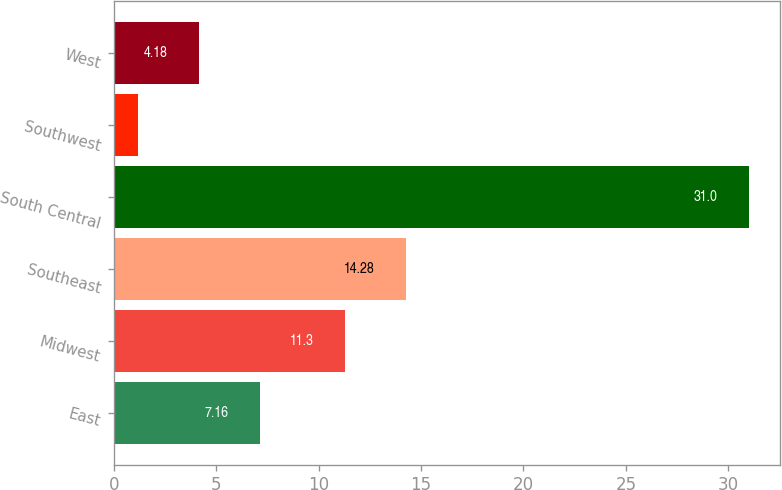Convert chart to OTSL. <chart><loc_0><loc_0><loc_500><loc_500><bar_chart><fcel>East<fcel>Midwest<fcel>Southeast<fcel>South Central<fcel>Southwest<fcel>West<nl><fcel>7.16<fcel>11.3<fcel>14.28<fcel>31<fcel>1.2<fcel>4.18<nl></chart> 